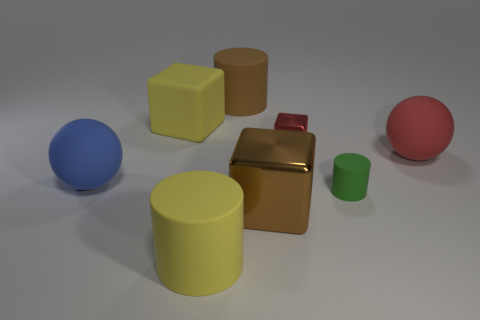Add 1 cyan cylinders. How many objects exist? 9 Subtract all big rubber cylinders. How many cylinders are left? 1 Subtract 1 balls. How many balls are left? 1 Subtract all yellow blocks. How many blocks are left? 2 Subtract all blocks. How many objects are left? 5 Add 4 tiny rubber cylinders. How many tiny rubber cylinders are left? 5 Add 1 large yellow metal spheres. How many large yellow metal spheres exist? 1 Subtract 0 yellow balls. How many objects are left? 8 Subtract all yellow spheres. Subtract all blue blocks. How many spheres are left? 2 Subtract all green matte objects. Subtract all tiny metallic things. How many objects are left? 6 